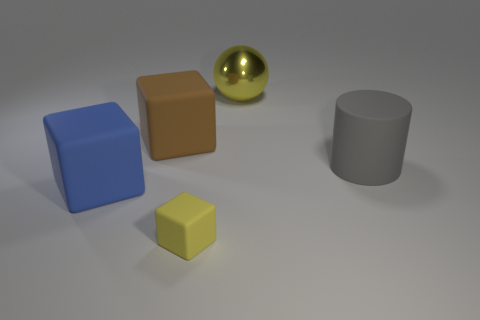What material is the big object that is the same color as the tiny block?
Provide a short and direct response. Metal. The other thing that is the same color as the small rubber thing is what size?
Offer a terse response. Large. What is the size of the blue object that is the same material as the big gray cylinder?
Your answer should be compact. Large. What is the shape of the other thing that is the same color as the metallic object?
Provide a short and direct response. Cube. Are there an equal number of tiny yellow blocks that are behind the blue cube and big yellow balls in front of the small yellow matte block?
Your answer should be compact. Yes. What number of other objects are there of the same size as the brown matte thing?
Your answer should be very brief. 3. How big is the yellow cube?
Make the answer very short. Small. Do the large blue block and the yellow object to the left of the metallic object have the same material?
Offer a terse response. Yes. Are there any gray objects of the same shape as the big blue rubber thing?
Ensure brevity in your answer.  No. What is the material of the yellow sphere that is the same size as the brown cube?
Give a very brief answer. Metal. 